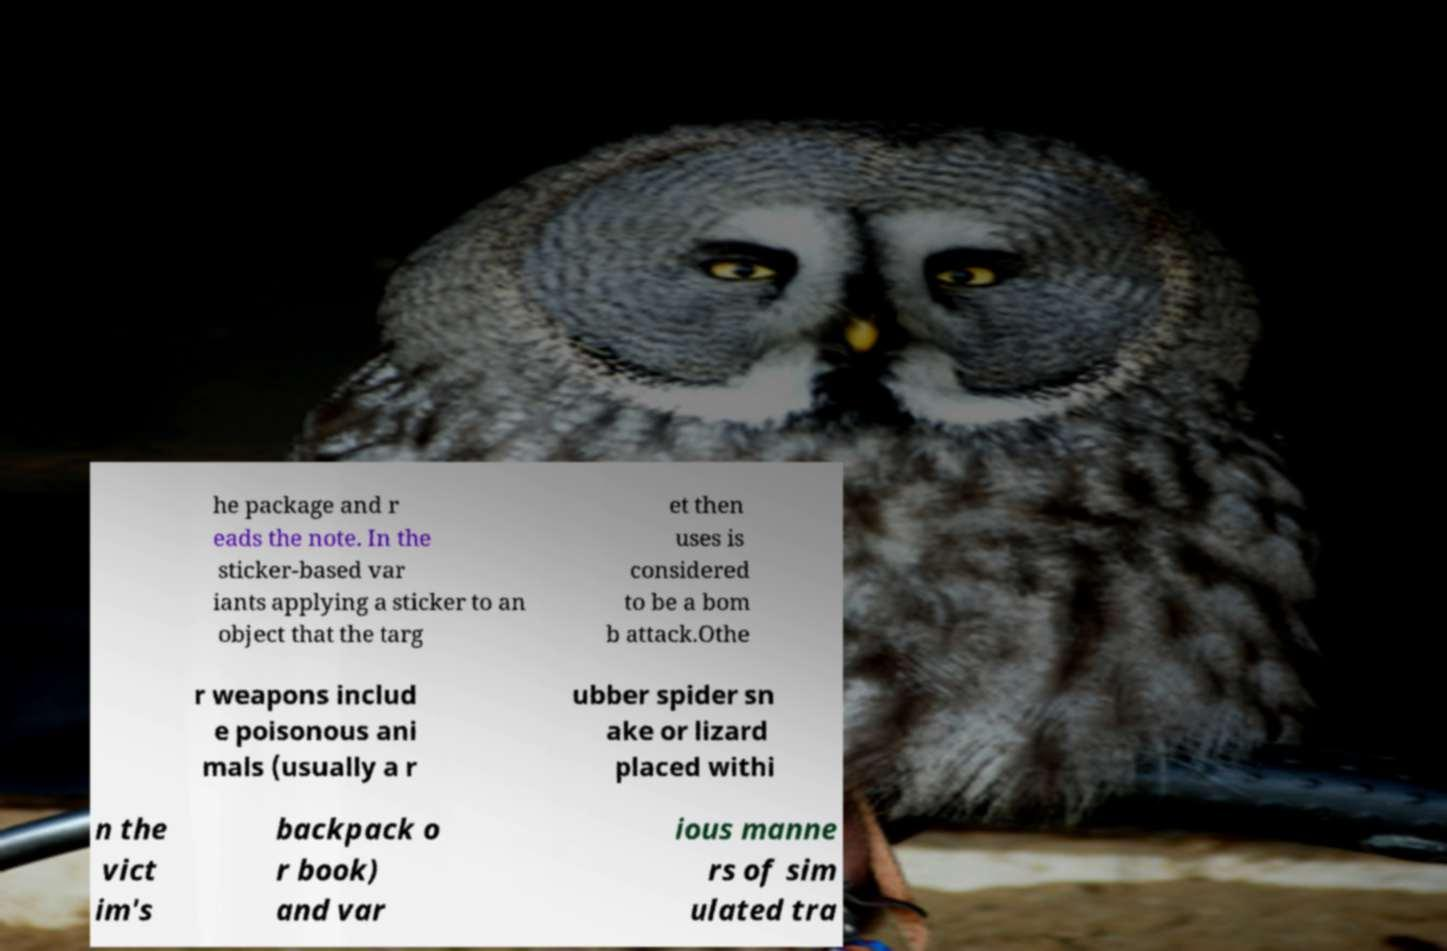What messages or text are displayed in this image? I need them in a readable, typed format. he package and r eads the note. In the sticker-based var iants applying a sticker to an object that the targ et then uses is considered to be a bom b attack.Othe r weapons includ e poisonous ani mals (usually a r ubber spider sn ake or lizard placed withi n the vict im's backpack o r book) and var ious manne rs of sim ulated tra 